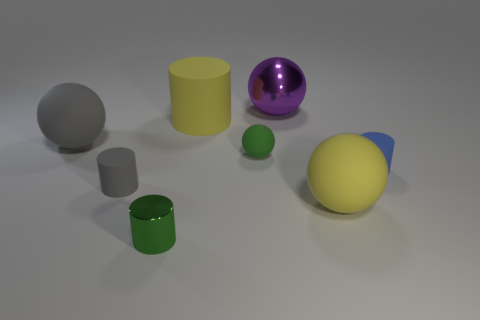Do the objects in the image suggest any particular use or context? The objects in the image don't suggest a specific use or context as they appear to be simplistic geometric shapes that could be found in a basic 3D modeling program. They might be used for teaching geometry or for practicing object rendering in graphic design and animation. The matte and reflective surfaces also suggest a study in texturing and lighting within a virtual scene. 